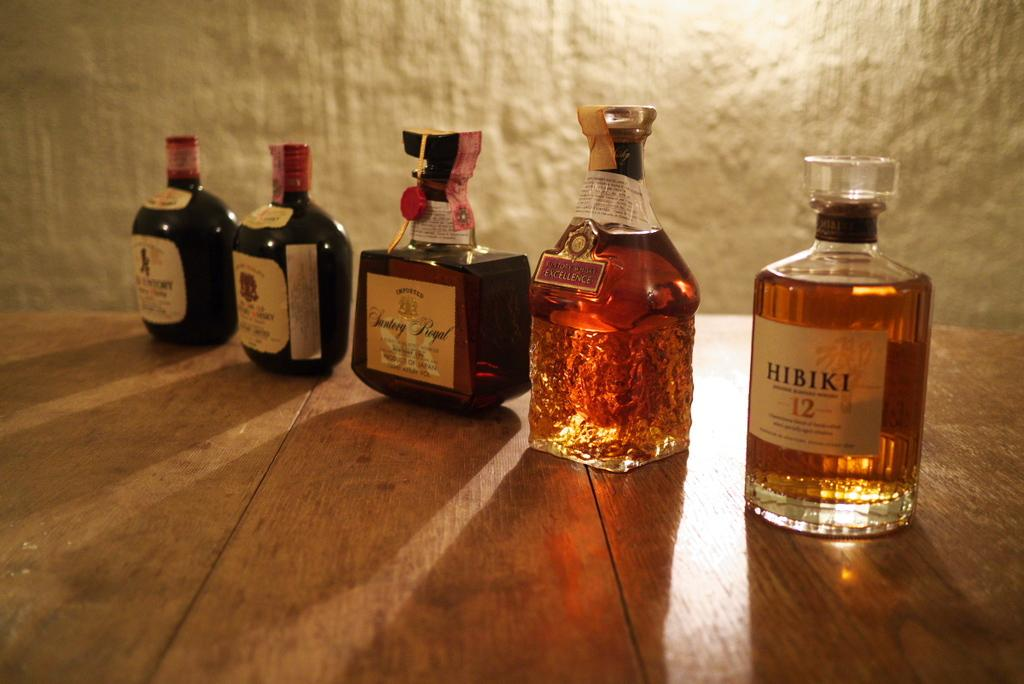Provide a one-sentence caption for the provided image. A bottle of Hibiki 12 sits next to other bottles, including a bottle of Santerg Royal, and are displayed on wood planks. 